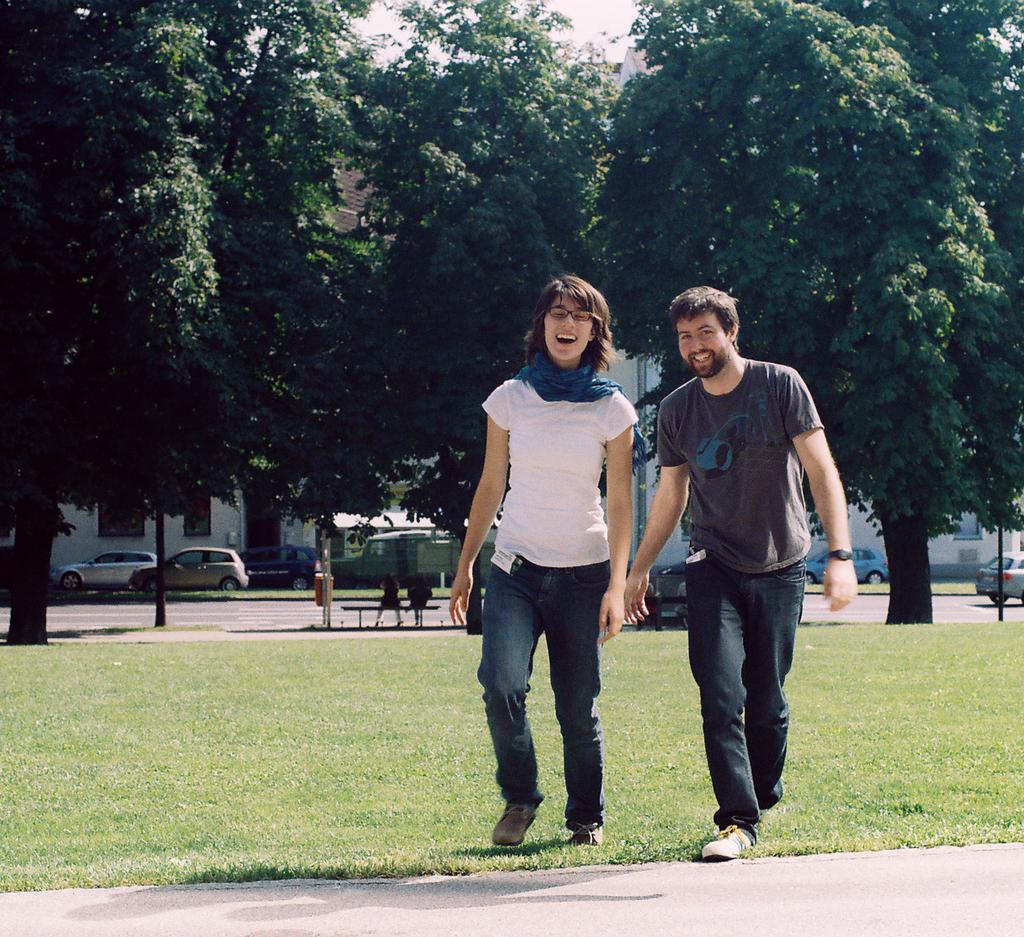How would you summarize this image in a sentence or two? In this image we can see two persons walking on the grass and in the background there are few trees, two persons sitting on a bench, there are few cars near the building and a car on the road. 